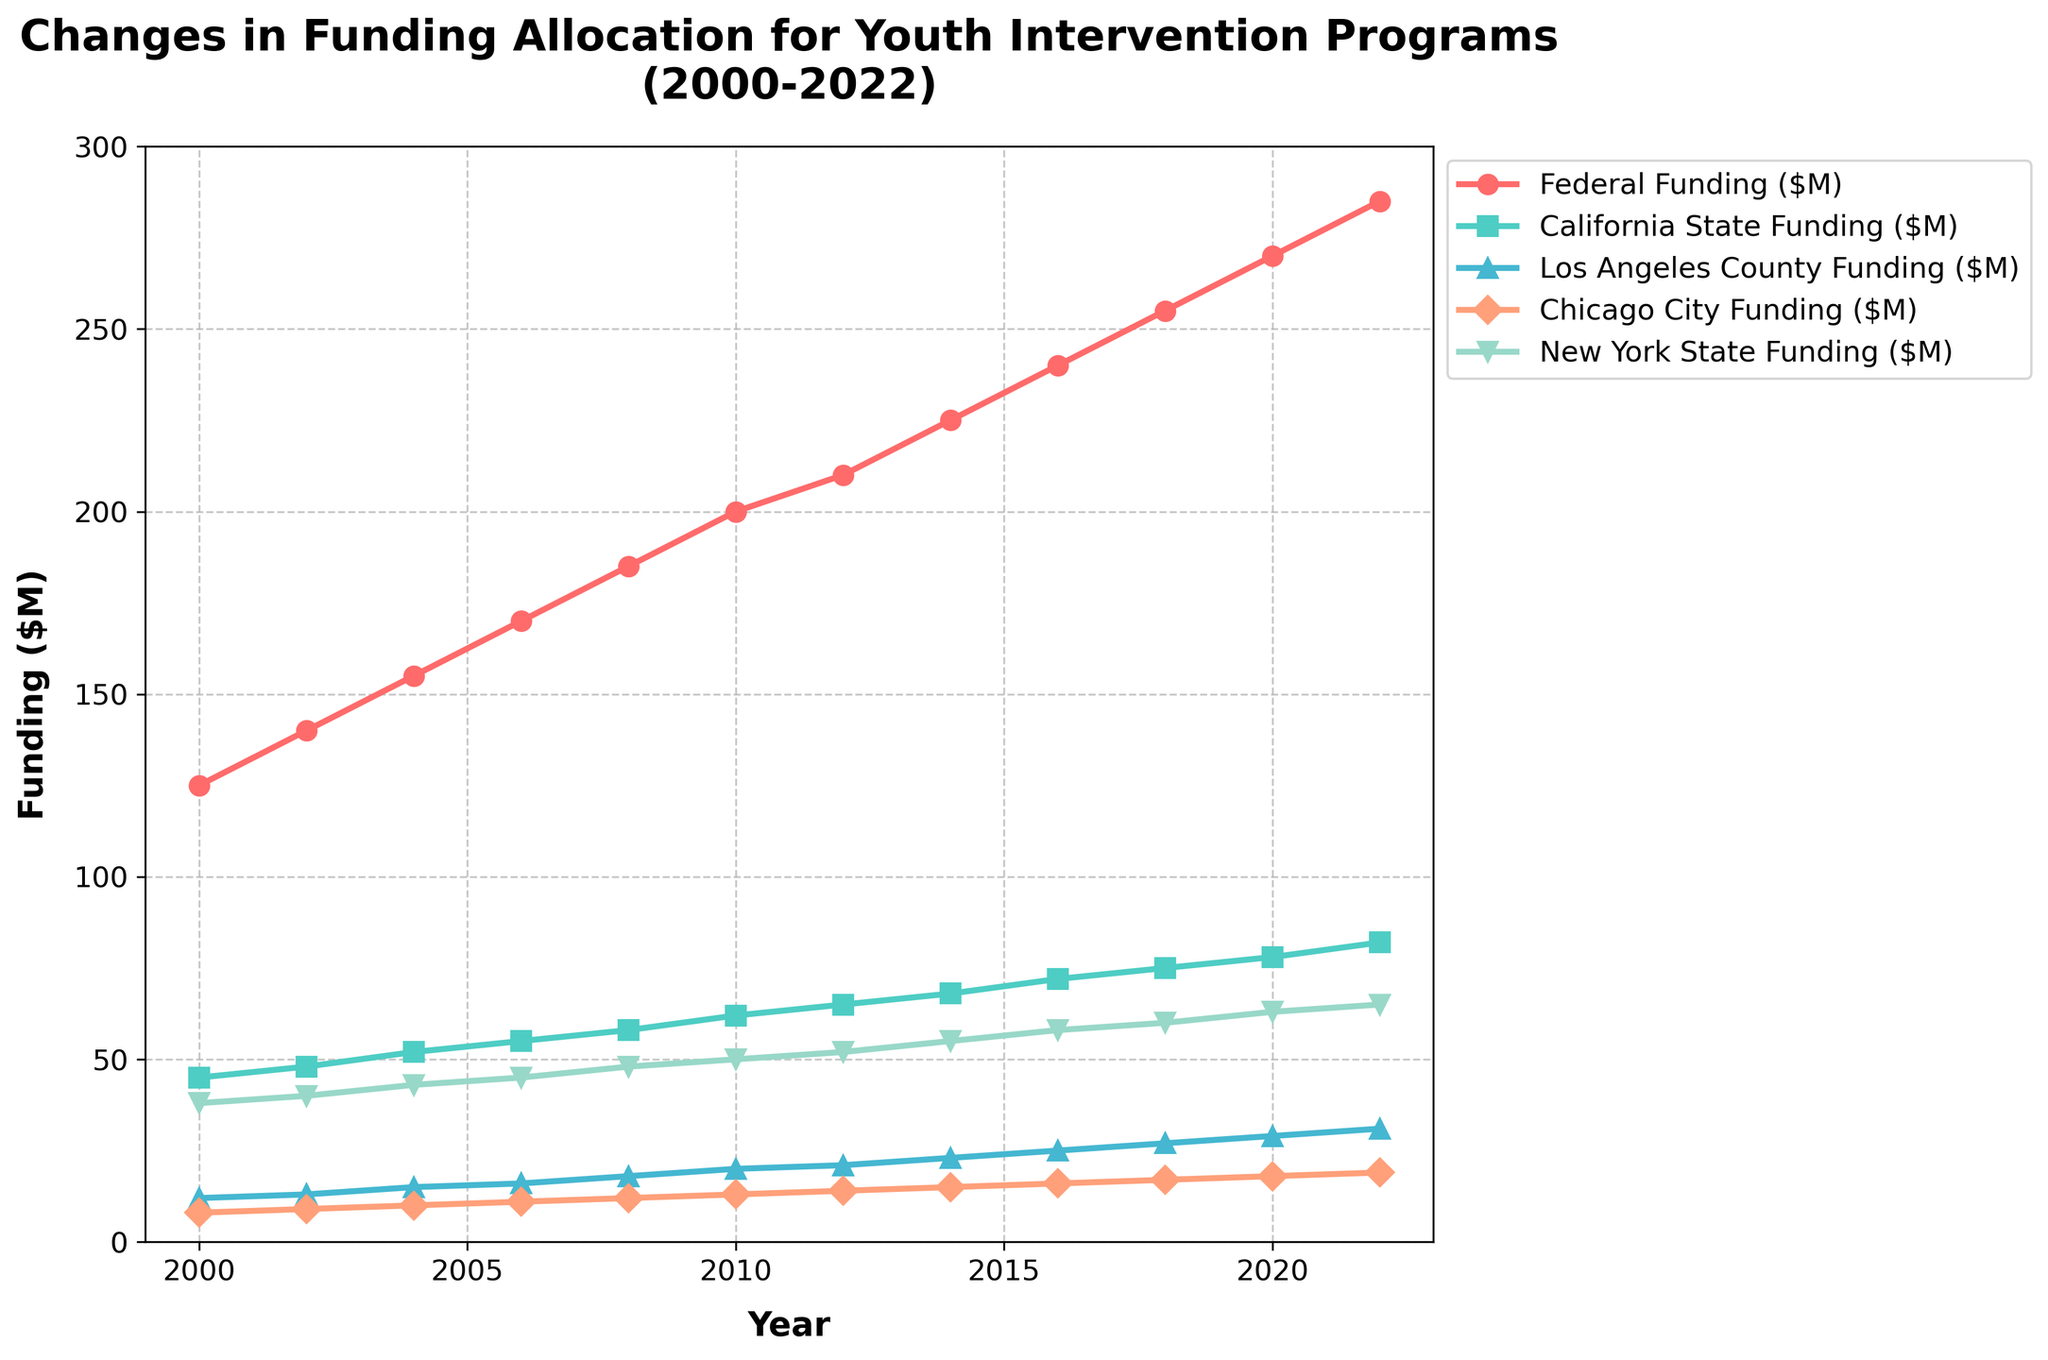what is the total amount of federal funding allocated over the years displayed in the figure? To find the total amount of federal funding allocated, sum the federal funding values for each year. (125 + 140 + 155 + 170 + 185 + 200 + 210 + 225 + 240 + 255 + 270 + 285) = 2460 million dollars.
Answer: 2460 million dollars In which year did New York State's funding reach 60 million dollars? Locate the line corresponding to New York State's funding and trace it to see when it intersects the 60 million dollar mark on the y-axis. This occurs in 2018.
Answer: 2018 Which entity had the steepest increase in funding between 2008 and 2010? Examine the slopes of the lines for each entity between 2008 and 2010. The rectangle representing Federal funding has the steepest slope among all, indicating the largest increase.
Answer: Federal funding How much higher is California State funding than Los Angeles County funding in 2020? Check the values for California State funding and Los Angeles County funding in 2020. California State: 78 million dollars; Los Angeles County: 29 million dollars; Difference = 78 - 29 = 49 million dollars.
Answer: 49 million dollars What is the average funding allocation for Chicago City from 2000 to 2022? Add the Chicago City funding values for each year and divide by the number of years. (8 + 9 + 10 + 11 + 12 + 13 + 14 + 15 + 16 + 17 + 18 + 19) / 12 = 14.33 million dollars.
Answer: 14.33 million dollars Which entity had the most gradual increase in funding from 2000 to 2022? Compare the slopes of the lines for each entity from 2000 to 2022. Chicago City's funding has the most gradual increase.
Answer: Chicago City How much did Federal funding increase from 2002 to 2020? Check the values for Federal funding in 2002 and 2020. 2020: 270 million dollars; 2002: 140 million dollars; Increase = 270 - 140 = 130 million dollars and subtract them.
Answer: 130 million dollars What is the trend for New York State funding over time? Observe the general direction of the New York State funding line over the years. It shows a consistent upward trend.
Answer: Consistent upward trend How many years did it take for California State funding to increase from 45 million dollars to 82 million dollars? Determine the years from the x-axis where the funding values correspond to 45 million dollars and 82 million dollars. 45 million dollars was in 2000 and 82 million dollars was in 2022. 2022 - 2000 = 22 years.
Answer: 22 years What is the highest funding level achieved by Los Angeles County? Identify the peak value for Los Angeles County funding line. The highest funding level for Los Angeles County is 31 million dollars in 2022.
Answer: 31 million dollars 